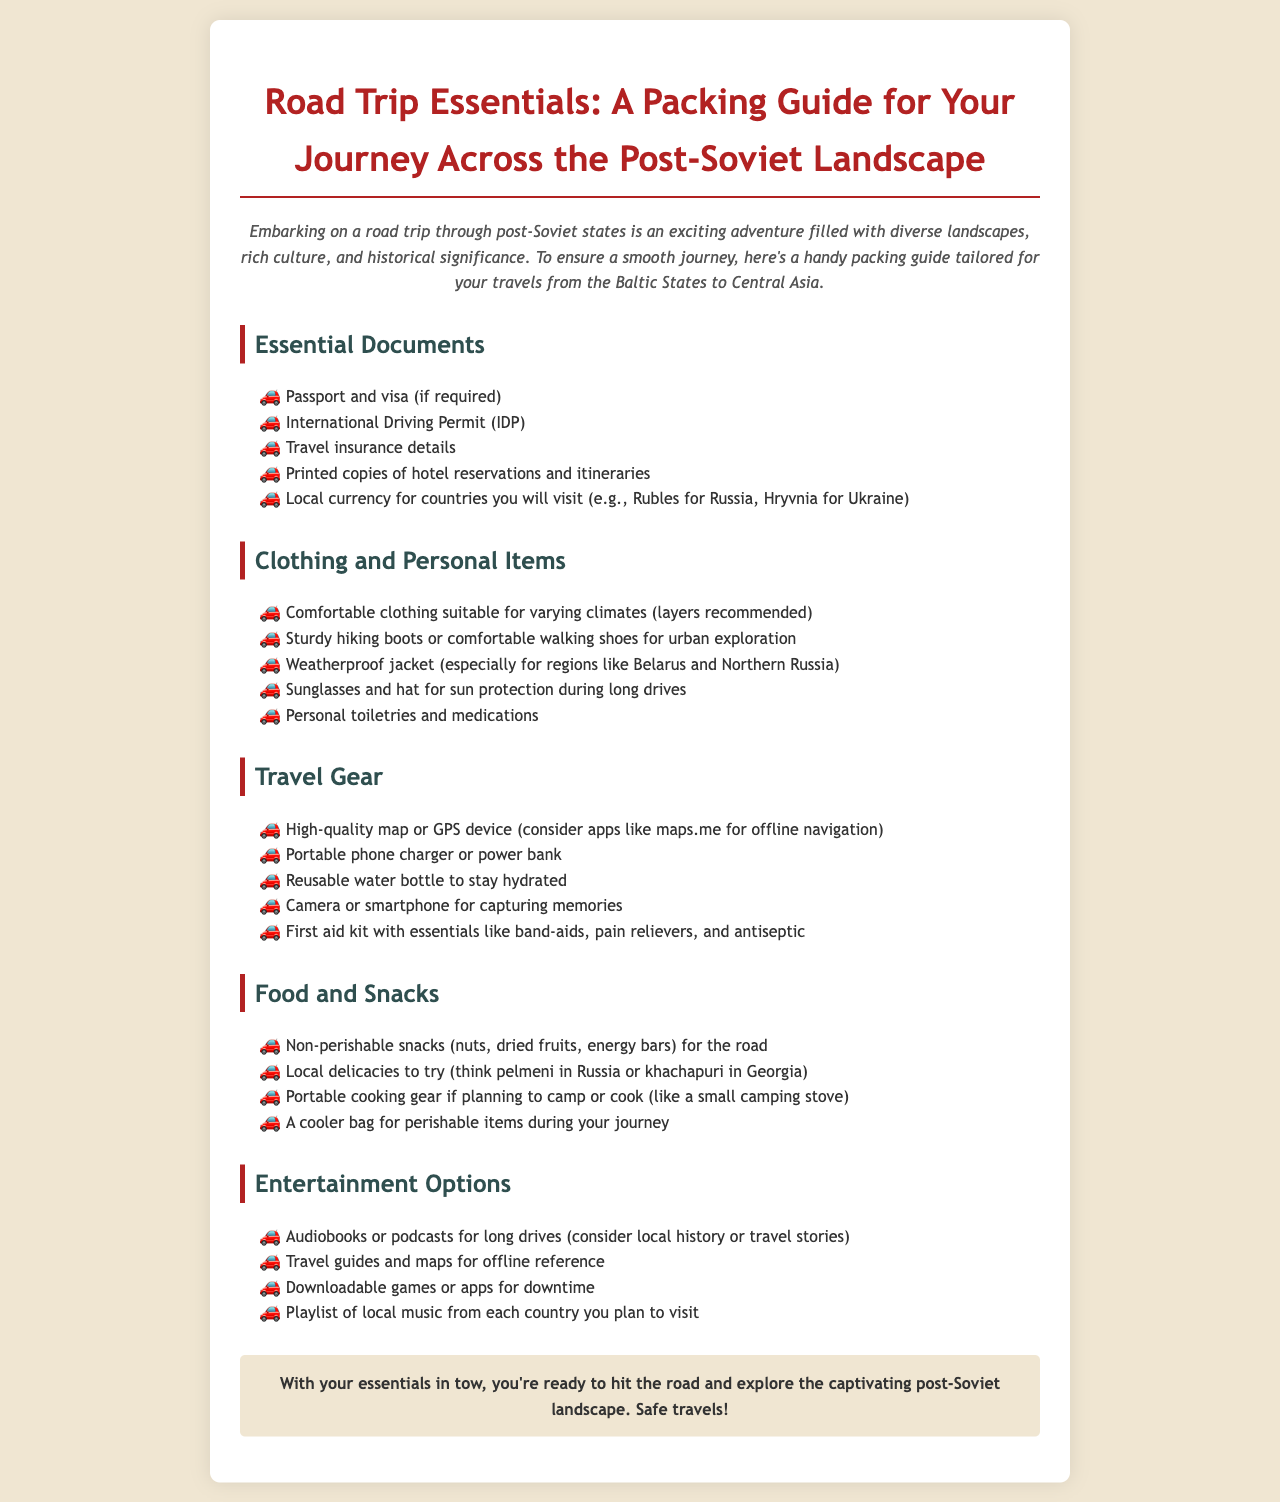What are two types of essential documents needed for the trip? The document lists essential documents required for the trip, including passport and visa, and International Driving Permit.
Answer: Passport and visa, International Driving Permit What should be included in personal items for clothing? The document mentions specific clothing items needed such as comfortable clothing, sturdy hiking boots, and a weatherproof jacket.
Answer: Comfortable clothing, sturdy hiking boots, weatherproof jacket Which travel gear is recommended for navigation? The document suggests a high-quality map or GPS device as important travel gear for navigation during the trip.
Answer: High-quality map or GPS device What is an example of a non-perishable snack? The document lists several non-perishable snacks to take on the trip, including dried fruits.
Answer: Dried fruits How can travelers stay entertained on long drives? The document offers suggestions for entertainment options, including audiobooks, podcasts, and a playlist of local music.
Answer: Audiobooks, podcasts, playlist of local music What type of jacket is recommended for the trip? The document advises that travelers should carry a weatherproof jacket, particularly for regions like Belarus and Northern Russia.
Answer: Weatherproof jacket What is a suggested local delicacy to try in Russia? The document highlights specific local delicacies to try while traveling, specifically mentioning pelmeni in Russia.
Answer: Pelmeni What should travelers carry to stay hydrated? The packing guide mentions a reusable water bottle as a way to stay hydrated during the journey.
Answer: Reusable water bottle What should be included in the first aid kit? The document specifies essentials like band-aids and pain relievers as items to include in a first aid kit.
Answer: Band-aids, pain relievers 